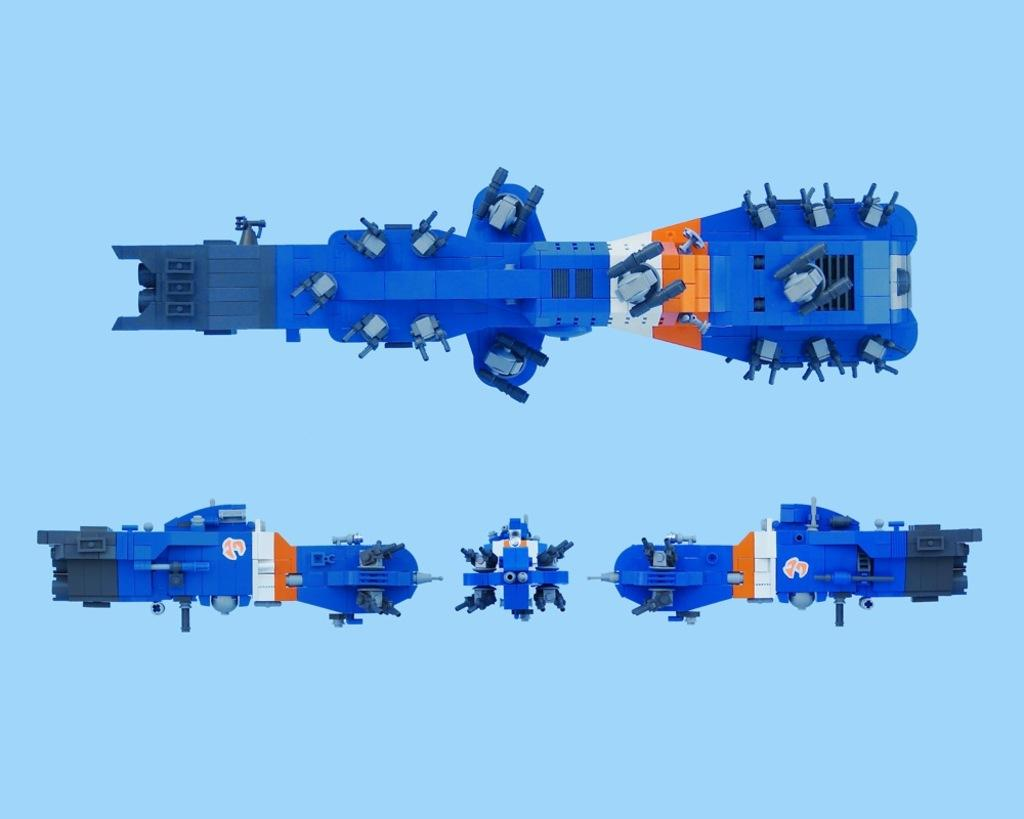What type of objects can be seen in the image? There are machine-like objects in the image. What material are the objects made of? The objects are made up of plastic building blocks. What type of rod is being used in the protest in the image? There is no protest or rod present in the image; it features machine-like objects made of plastic building blocks. Can you tell me the name of the sister who is also present in the image? There is no person, including a sister, present in the image. 